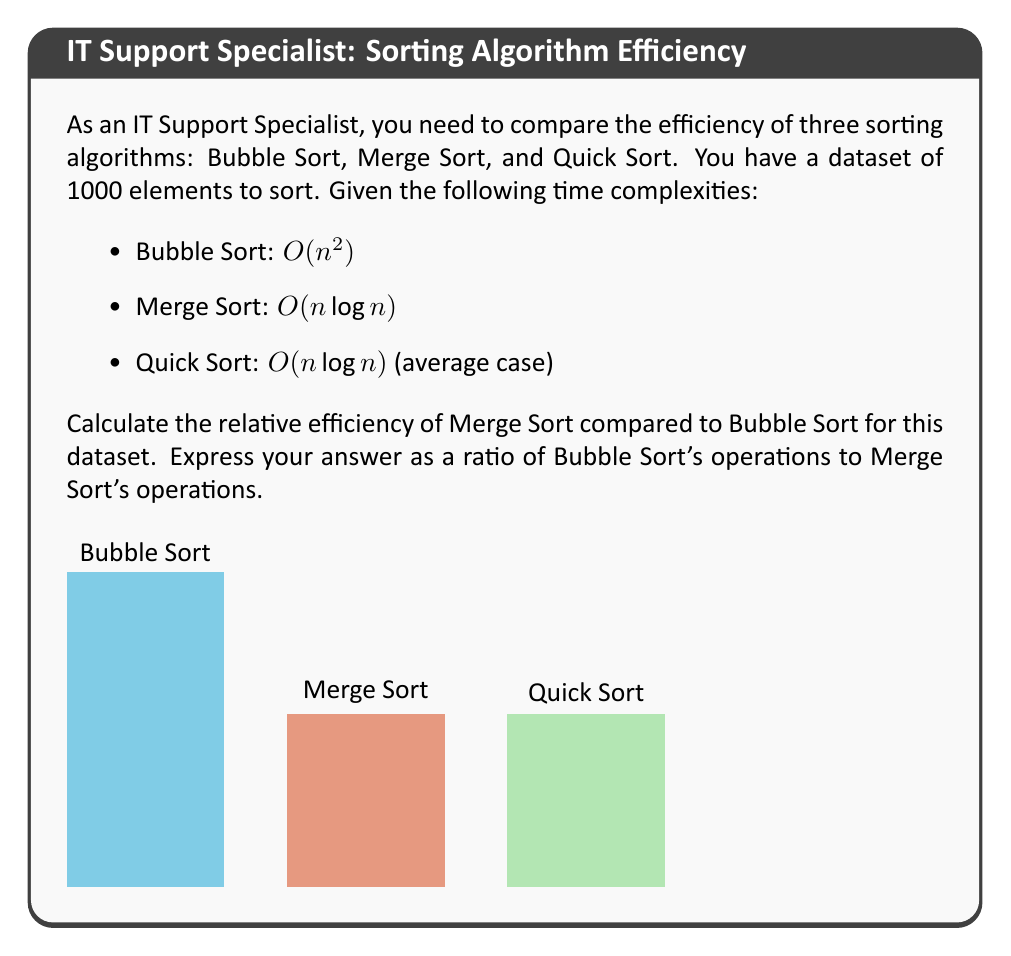Solve this math problem. Let's approach this step-by-step:

1) First, let's calculate the number of operations for each algorithm:

   Bubble Sort: $O(n^2) = 1000^2 = 1,000,000$ operations
   Merge Sort: $O(n \log n) = 1000 \log 1000 \approx 1000 * 10 = 10,000$ operations

2) To find the relative efficiency, we need to calculate the ratio of Bubble Sort operations to Merge Sort operations:

   $$\text{Ratio} = \frac{\text{Bubble Sort operations}}{\text{Merge Sort operations}} = \frac{1,000,000}{10,000} = 100$$

3) This means Bubble Sort performs 100 times more operations than Merge Sort for this dataset size.

4) To express this as a ratio, we can write it as 100:1.

Therefore, the relative efficiency of Merge Sort compared to Bubble Sort for a dataset of 1000 elements is 100:1, meaning Bubble Sort requires 100 times more operations than Merge Sort.
Answer: 100:1 